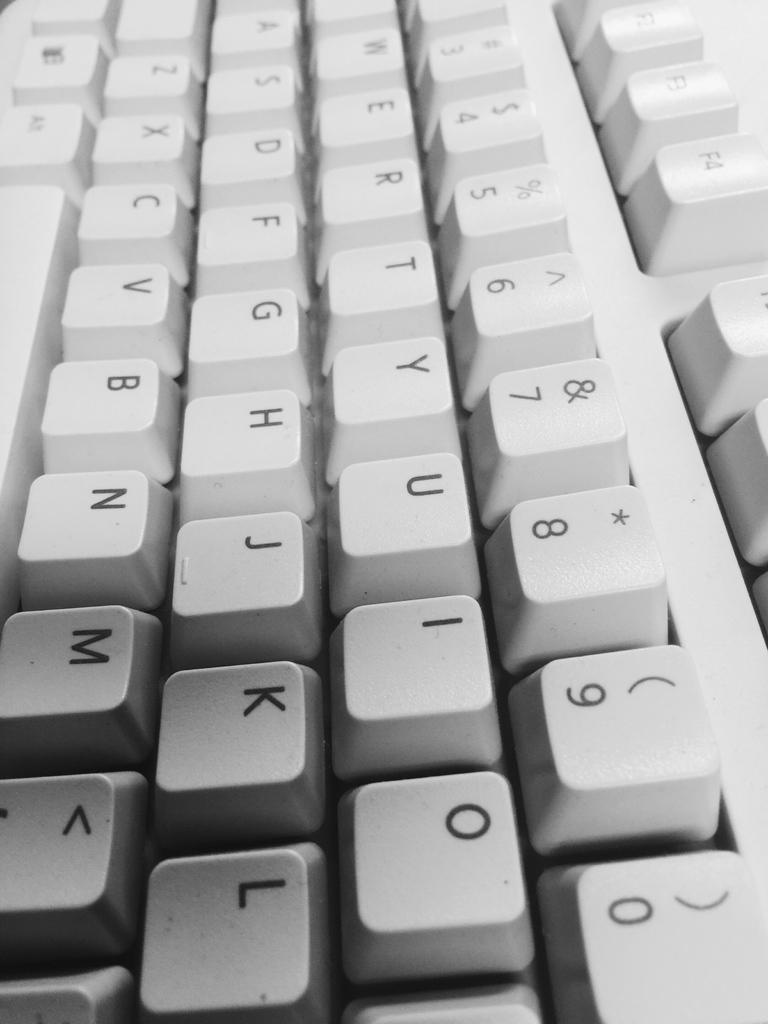Provide a one-sentence caption for the provided image. A gray qwerty keyboard is shown up close. 